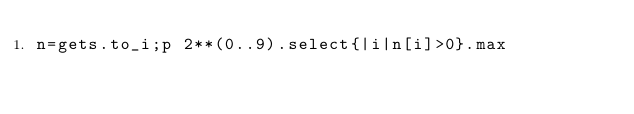<code> <loc_0><loc_0><loc_500><loc_500><_Ruby_>n=gets.to_i;p 2**(0..9).select{|i|n[i]>0}.max</code> 